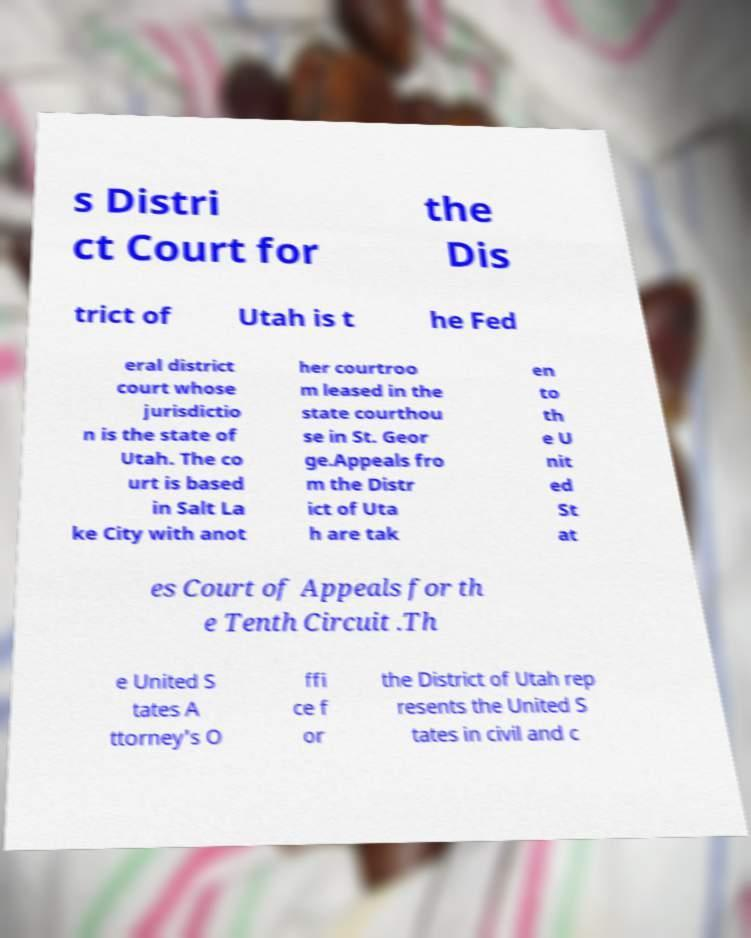Please identify and transcribe the text found in this image. s Distri ct Court for the Dis trict of Utah is t he Fed eral district court whose jurisdictio n is the state of Utah. The co urt is based in Salt La ke City with anot her courtroo m leased in the state courthou se in St. Geor ge.Appeals fro m the Distr ict of Uta h are tak en to th e U nit ed St at es Court of Appeals for th e Tenth Circuit .Th e United S tates A ttorney's O ffi ce f or the District of Utah rep resents the United S tates in civil and c 